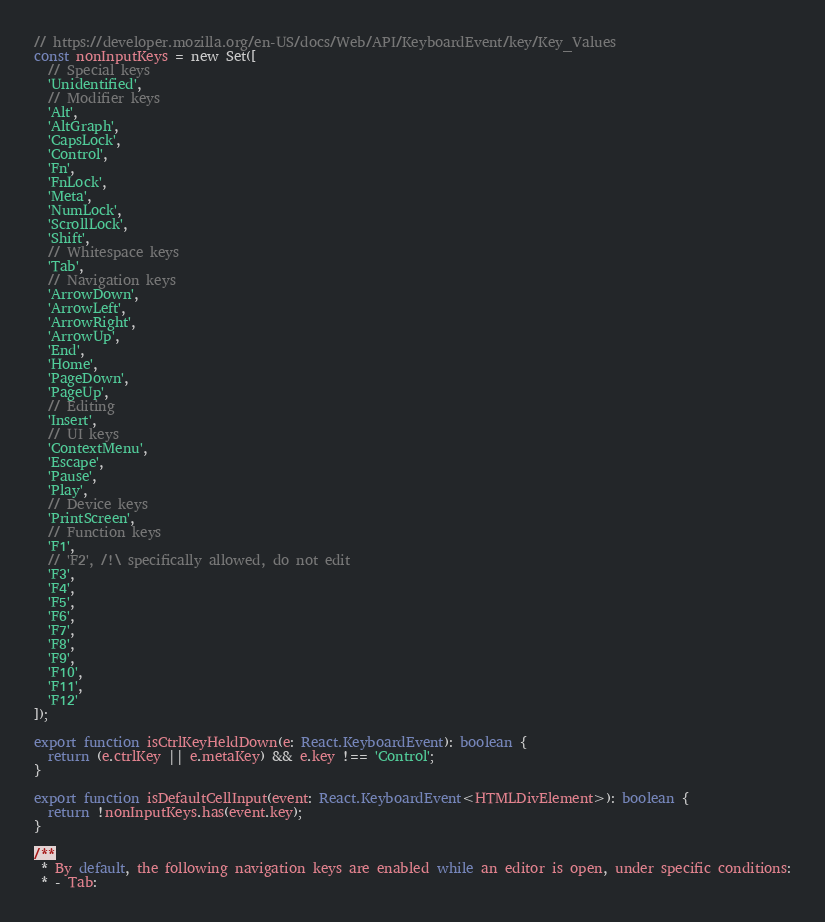<code> <loc_0><loc_0><loc_500><loc_500><_TypeScript_>// https://developer.mozilla.org/en-US/docs/Web/API/KeyboardEvent/key/Key_Values
const nonInputKeys = new Set([
  // Special keys
  'Unidentified',
  // Modifier keys
  'Alt',
  'AltGraph',
  'CapsLock',
  'Control',
  'Fn',
  'FnLock',
  'Meta',
  'NumLock',
  'ScrollLock',
  'Shift',
  // Whitespace keys
  'Tab',
  // Navigation keys
  'ArrowDown',
  'ArrowLeft',
  'ArrowRight',
  'ArrowUp',
  'End',
  'Home',
  'PageDown',
  'PageUp',
  // Editing
  'Insert',
  // UI keys
  'ContextMenu',
  'Escape',
  'Pause',
  'Play',
  // Device keys
  'PrintScreen',
  // Function keys
  'F1',
  // 'F2', /!\ specifically allowed, do not edit
  'F3',
  'F4',
  'F5',
  'F6',
  'F7',
  'F8',
  'F9',
  'F10',
  'F11',
  'F12'
]);

export function isCtrlKeyHeldDown(e: React.KeyboardEvent): boolean {
  return (e.ctrlKey || e.metaKey) && e.key !== 'Control';
}

export function isDefaultCellInput(event: React.KeyboardEvent<HTMLDivElement>): boolean {
  return !nonInputKeys.has(event.key);
}

/**
 * By default, the following navigation keys are enabled while an editor is open, under specific conditions:
 * - Tab:</code> 